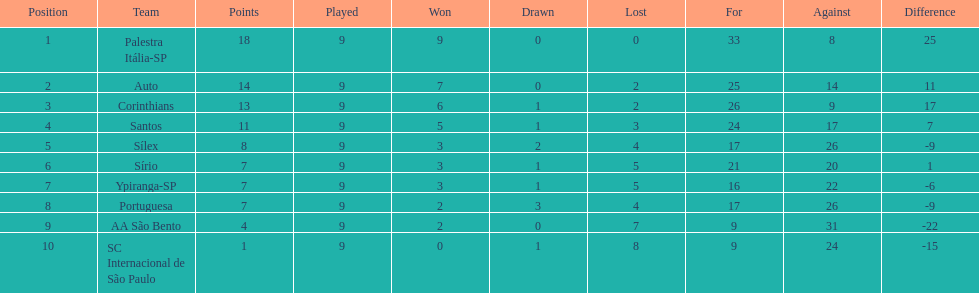Would you be able to parse every entry in this table? {'header': ['Position', 'Team', 'Points', 'Played', 'Won', 'Drawn', 'Lost', 'For', 'Against', 'Difference'], 'rows': [['1', 'Palestra Itália-SP', '18', '9', '9', '0', '0', '33', '8', '25'], ['2', 'Auto', '14', '9', '7', '0', '2', '25', '14', '11'], ['3', 'Corinthians', '13', '9', '6', '1', '2', '26', '9', '17'], ['4', 'Santos', '11', '9', '5', '1', '3', '24', '17', '7'], ['5', 'Sílex', '8', '9', '3', '2', '4', '17', '26', '-9'], ['6', 'Sírio', '7', '9', '3', '1', '5', '21', '20', '1'], ['7', 'Ypiranga-SP', '7', '9', '3', '1', '5', '16', '22', '-6'], ['8', 'Portuguesa', '7', '9', '2', '3', '4', '17', '26', '-9'], ['9', 'AA São Bento', '4', '9', '2', '0', '7', '9', '31', '-22'], ['10', 'SC Internacional de São Paulo', '1', '9', '0', '1', '8', '9', '24', '-15']]} In 1926 brazilian football,aside from the first place team, what other teams had winning records? Auto, Corinthians, Santos. 